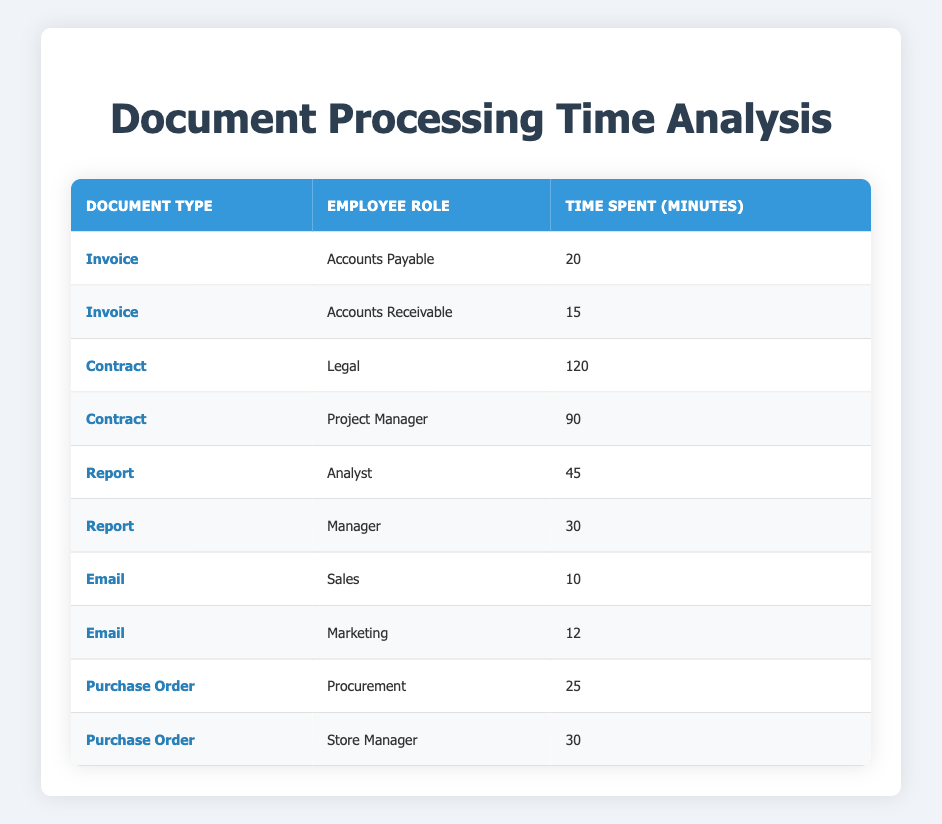What is the time spent by the Accounts Payable role on processing Invoices? The table explicitly shows that the Accounts Payable role spends 20 minutes on Invoices.
Answer: 20 minutes Which document type takes the least amount of time to process by all employees? By reviewing the time spent for all document types, Emails take the least time with 10 and 12 minutes.
Answer: Email What is the total time spent by the Legal role on Contracts? The Legal role spends 120 minutes on Contracts. Therefore, the total time is 120 minutes.
Answer: 120 minutes Is the time spent by the Procurement role less than the time spent by the Store Manager role? The Procurement role spends 25 minutes, while the Store Manager spends 30 minutes. Since 25 is less than 30, the statement is true.
Answer: Yes What is the average time spent on processing Reports? The time spent on Reports is 45 minutes by Analysts and 30 minutes by Managers. The sum is 45 + 30 = 75 minutes. There are 2 entries, so the average is 75/2 = 37.5 minutes.
Answer: 37.5 minutes How much more time do Legal employees spend compared to Accounts Receivable employees on their respective primary documents? Legal spends 120 minutes on Contracts and Accounts Receivable spends 15 minutes on Invoices. The difference is 120 - 15 = 105 minutes more for Legal.
Answer: 105 minutes Does the Marketing role spend more time on Emails than the Accounts Payable spends on Invoices? The time spent by Marketing on Emails is 12 minutes, while Accounts Payable spends 20 minutes on Invoices. Since 12 is less than 20, the statement is false.
Answer: No Which document type is processed the most time-consuming on average? To find this, we average the time of each type: Invoices (20 + 15)/2 = 17.5, Contracts (120 + 90)/2 = 105, Reports (45 + 30)/2 = 37.5, Emails (10 + 12)/2 = 11, Purchase Orders (25 + 30)/2 = 27.5. Contracts have the highest average of 105 minutes.
Answer: Contracts 